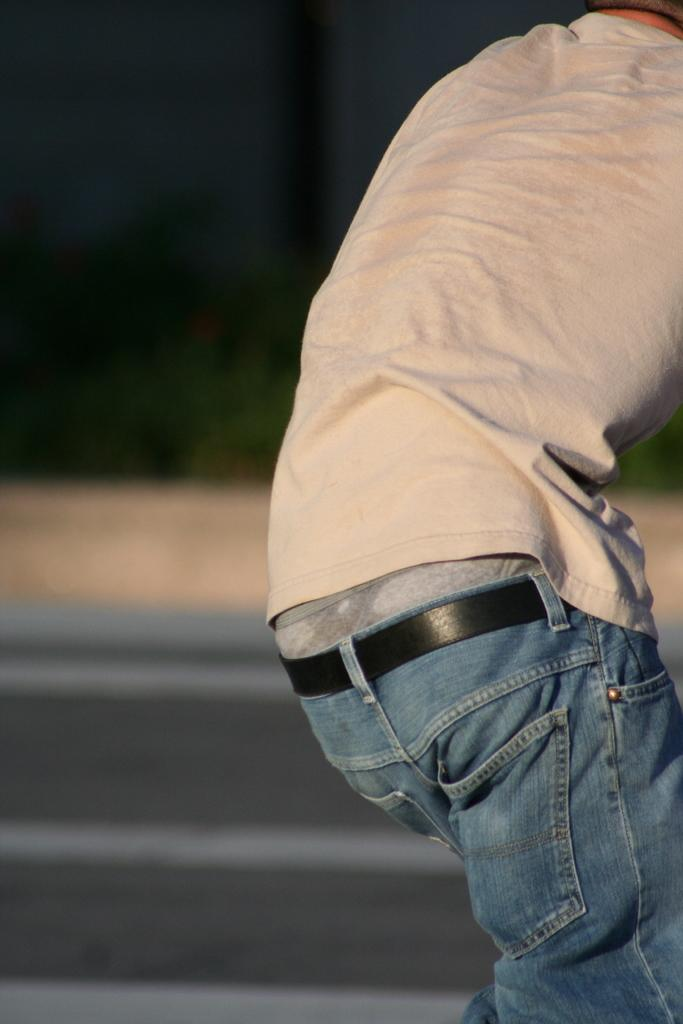What is the main subject in the foreground of the image? There is a person in the foreground of the image. How would you describe the background of the image? The background of the image is blurred. What type of surface can be seen at the bottom of the image? There is a road at the bottom of the image. What type of metal is used to make the quilt in the image? There is no quilt present in the image, and therefore no metal can be associated with it. 